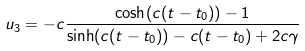<formula> <loc_0><loc_0><loc_500><loc_500>u _ { 3 } = - c \frac { \cosh ( c ( t - t _ { 0 } ) ) - 1 } { \sinh ( c ( t - t _ { 0 } ) ) - c ( t - t _ { 0 } ) + 2 c \gamma }</formula> 